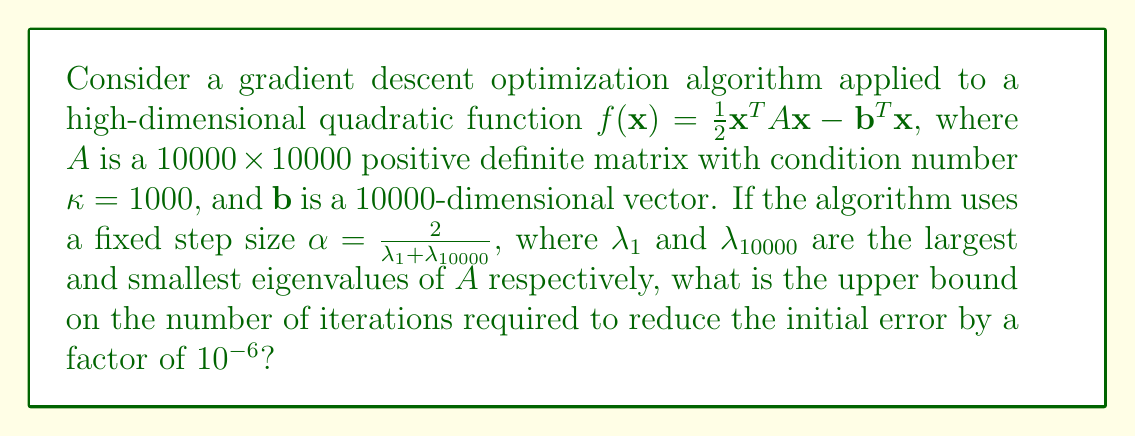Could you help me with this problem? To solve this problem, we'll follow these steps:

1) For a quadratic function, the convergence rate of gradient descent with a fixed step size is governed by the condition number $\kappa$ of the matrix $A$.

2) The optimal fixed step size for gradient descent is $\alpha = \frac{2}{\lambda_1 + \lambda_{10000}}$, which is given in the problem.

3) With this step size, the error reduction after $k$ iterations is bounded by:

   $$\frac{\|\mathbf{x}_k - \mathbf{x}^*\|}{\|\mathbf{x}_0 - \mathbf{x}^*\|} \leq \left(\frac{\kappa - 1}{\kappa + 1}\right)^k$$

   where $\mathbf{x}^*$ is the optimal solution.

4) We want to find $k$ such that:

   $$\left(\frac{\kappa - 1}{\kappa + 1}\right)^k \leq 10^{-6}$$

5) Taking logarithms of both sides:

   $$k \log\left(\frac{\kappa - 1}{\kappa + 1}\right) \leq \log(10^{-6})$$

6) Solving for $k$:

   $$k \geq \frac{\log(10^{-6})}{\log\left(\frac{\kappa - 1}{\kappa + 1}\right)}$$

7) Substituting $\kappa = 1000$:

   $$k \geq \frac{\log(10^{-6})}{\log\left(\frac{999}{1001}\right)} \approx 6907.75$$

8) Since $k$ must be an integer, we round up to get the upper bound.
Answer: 6908 iterations 